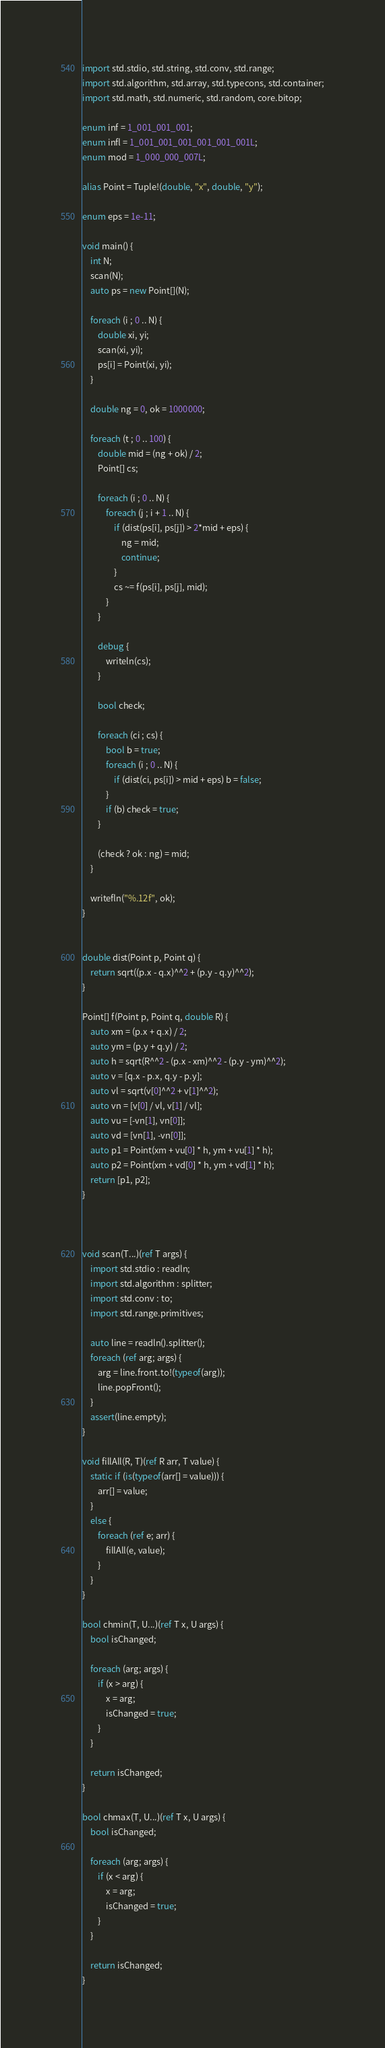Convert code to text. <code><loc_0><loc_0><loc_500><loc_500><_D_>import std.stdio, std.string, std.conv, std.range;
import std.algorithm, std.array, std.typecons, std.container;
import std.math, std.numeric, std.random, core.bitop;

enum inf = 1_001_001_001;
enum infl = 1_001_001_001_001_001_001L;
enum mod = 1_000_000_007L;

alias Point = Tuple!(double, "x", double, "y");

enum eps = 1e-11;

void main() {
    int N;
    scan(N);
    auto ps = new Point[](N);

    foreach (i ; 0 .. N) {
        double xi, yi;
        scan(xi, yi);
        ps[i] = Point(xi, yi);
    }

    double ng = 0, ok = 1000000;

    foreach (t ; 0 .. 100) {
        double mid = (ng + ok) / 2;
        Point[] cs;

        foreach (i ; 0 .. N) {
            foreach (j ; i + 1 .. N) {
                if (dist(ps[i], ps[j]) > 2*mid + eps) {
                    ng = mid;
                    continue;
                }
                cs ~= f(ps[i], ps[j], mid);
            }
        }

        debug {
            writeln(cs);
        }

        bool check;

        foreach (ci ; cs) {
            bool b = true;
            foreach (i ; 0 .. N) {
                if (dist(ci, ps[i]) > mid + eps) b = false;
            }
            if (b) check = true;
        }

        (check ? ok : ng) = mid;
    }

    writefln("%.12f", ok);
}


double dist(Point p, Point q) {
    return sqrt((p.x - q.x)^^2 + (p.y - q.y)^^2);
}

Point[] f(Point p, Point q, double R) {
    auto xm = (p.x + q.x) / 2;
    auto ym = (p.y + q.y) / 2;
    auto h = sqrt(R^^2 - (p.x - xm)^^2 - (p.y - ym)^^2);
    auto v = [q.x - p.x, q.y - p.y];
    auto vl = sqrt(v[0]^^2 + v[1]^^2);
    auto vn = [v[0] / vl, v[1] / vl];
    auto vu = [-vn[1], vn[0]];
    auto vd = [vn[1], -vn[0]];
    auto p1 = Point(xm + vu[0] * h, ym + vu[1] * h);
    auto p2 = Point(xm + vd[0] * h, ym + vd[1] * h);
    return [p1, p2];
}



void scan(T...)(ref T args) {
    import std.stdio : readln;
    import std.algorithm : splitter;
    import std.conv : to;
    import std.range.primitives;

    auto line = readln().splitter();
    foreach (ref arg; args) {
        arg = line.front.to!(typeof(arg));
        line.popFront();
    }
    assert(line.empty);
}

void fillAll(R, T)(ref R arr, T value) {
    static if (is(typeof(arr[] = value))) {
        arr[] = value;
    }
    else {
        foreach (ref e; arr) {
            fillAll(e, value);
        }
    }
}

bool chmin(T, U...)(ref T x, U args) {
    bool isChanged;

    foreach (arg; args) {
        if (x > arg) {
            x = arg;
            isChanged = true;
        }
    }

    return isChanged;
}

bool chmax(T, U...)(ref T x, U args) {
    bool isChanged;

    foreach (arg; args) {
        if (x < arg) {
            x = arg;
            isChanged = true;
        }
    }

    return isChanged;
}
</code> 